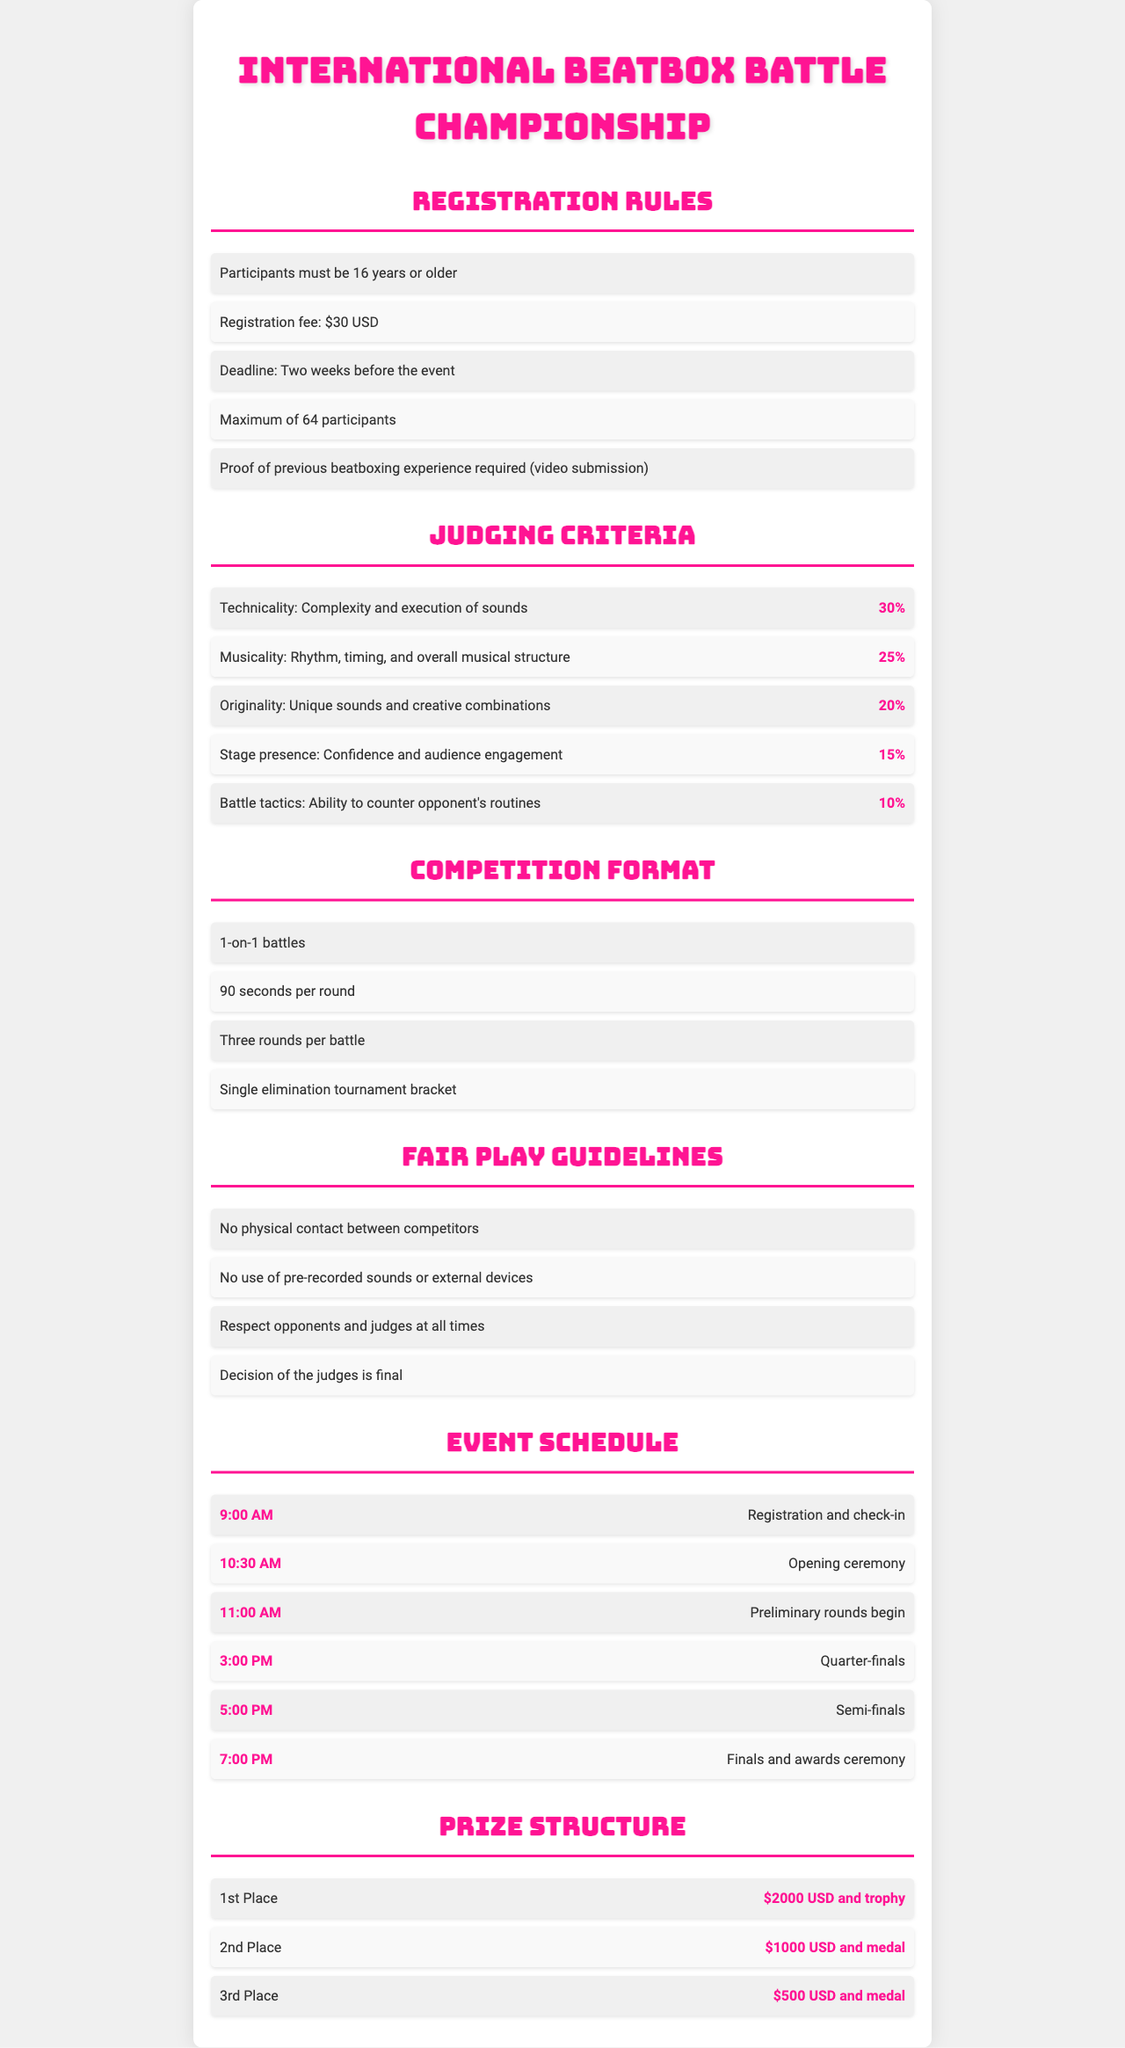What is the minimum age for participants? The document states that participants must be 16 years or older.
Answer: 16 years What is the registration fee? The registration fee mentioned in the document is $30 USD.
Answer: $30 USD How many judges are involved in the competition? The document does not specify the number of judges, only detailing the judging criteria.
Answer: Not specified What percentage of the score is attributed to technicality? The document indicates that technicality accounts for 30% of the score.
Answer: 30% What type of competition format is followed? The competition format outlined in the document is 1-on-1 battles.
Answer: 1-on-1 battles Is physical contact allowed during the competition? The guidelines state that no physical contact between competitors is allowed.
Answer: No What time does the preliminary round begin? According to the schedule, the preliminary rounds begin at 11:00 AM.
Answer: 11:00 AM What is the prize for the 2nd place? The document specifies that the 2nd place prize is $1000 USD and a medal.
Answer: $1000 USD and medal How many rounds are there per battle? Each battle consists of three rounds as mentioned in the document.
Answer: Three rounds 